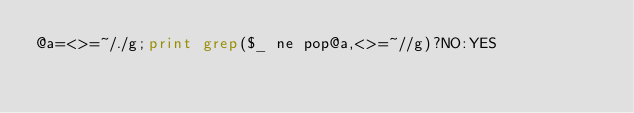Convert code to text. <code><loc_0><loc_0><loc_500><loc_500><_Perl_>@a=<>=~/./g;print grep($_ ne pop@a,<>=~//g)?NO:YES</code> 